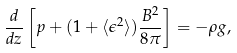<formula> <loc_0><loc_0><loc_500><loc_500>\frac { d } { d z } \left [ p + ( 1 + \langle \epsilon ^ { 2 } \rangle ) \frac { B ^ { 2 } } { 8 \pi } \right ] = - \rho g ,</formula> 